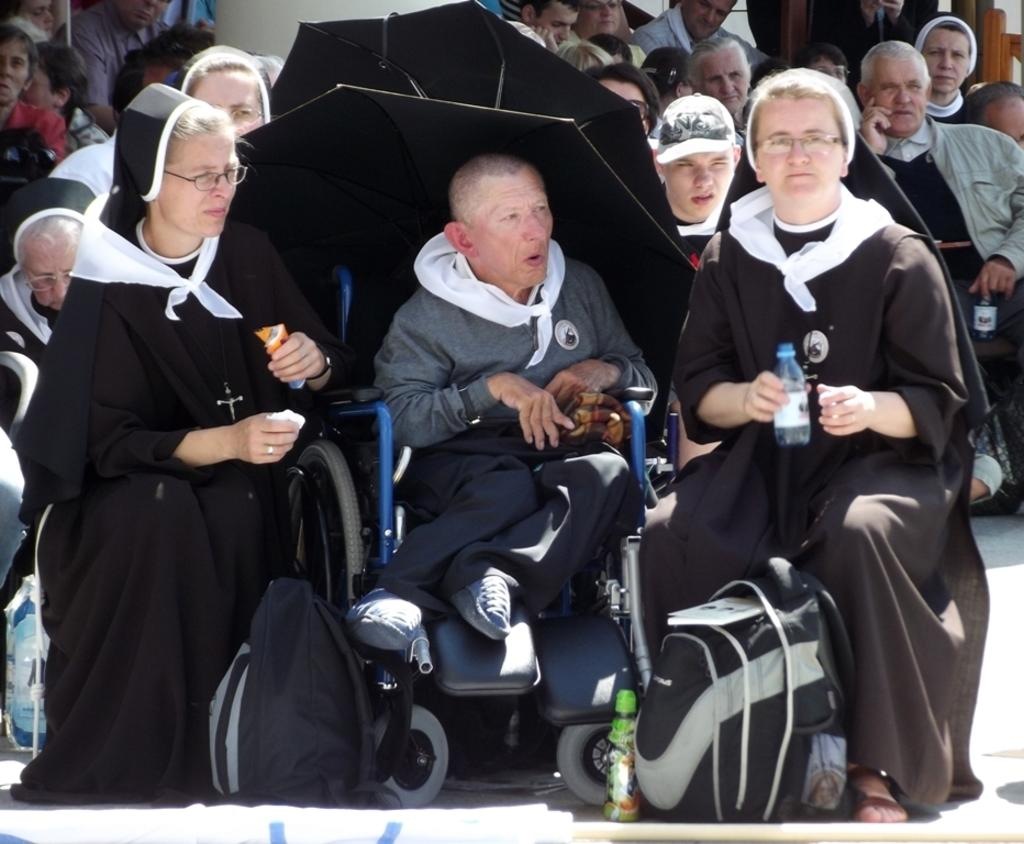What are the people in the image doing? The people in the image are sitting. What objects can be seen on the ground in the image? There are two bags on the ground in the image. Can you see any goldfish swimming in the image? There are no goldfish present in the image. Is there any steam visible in the image? There is no steam visible in the image. 